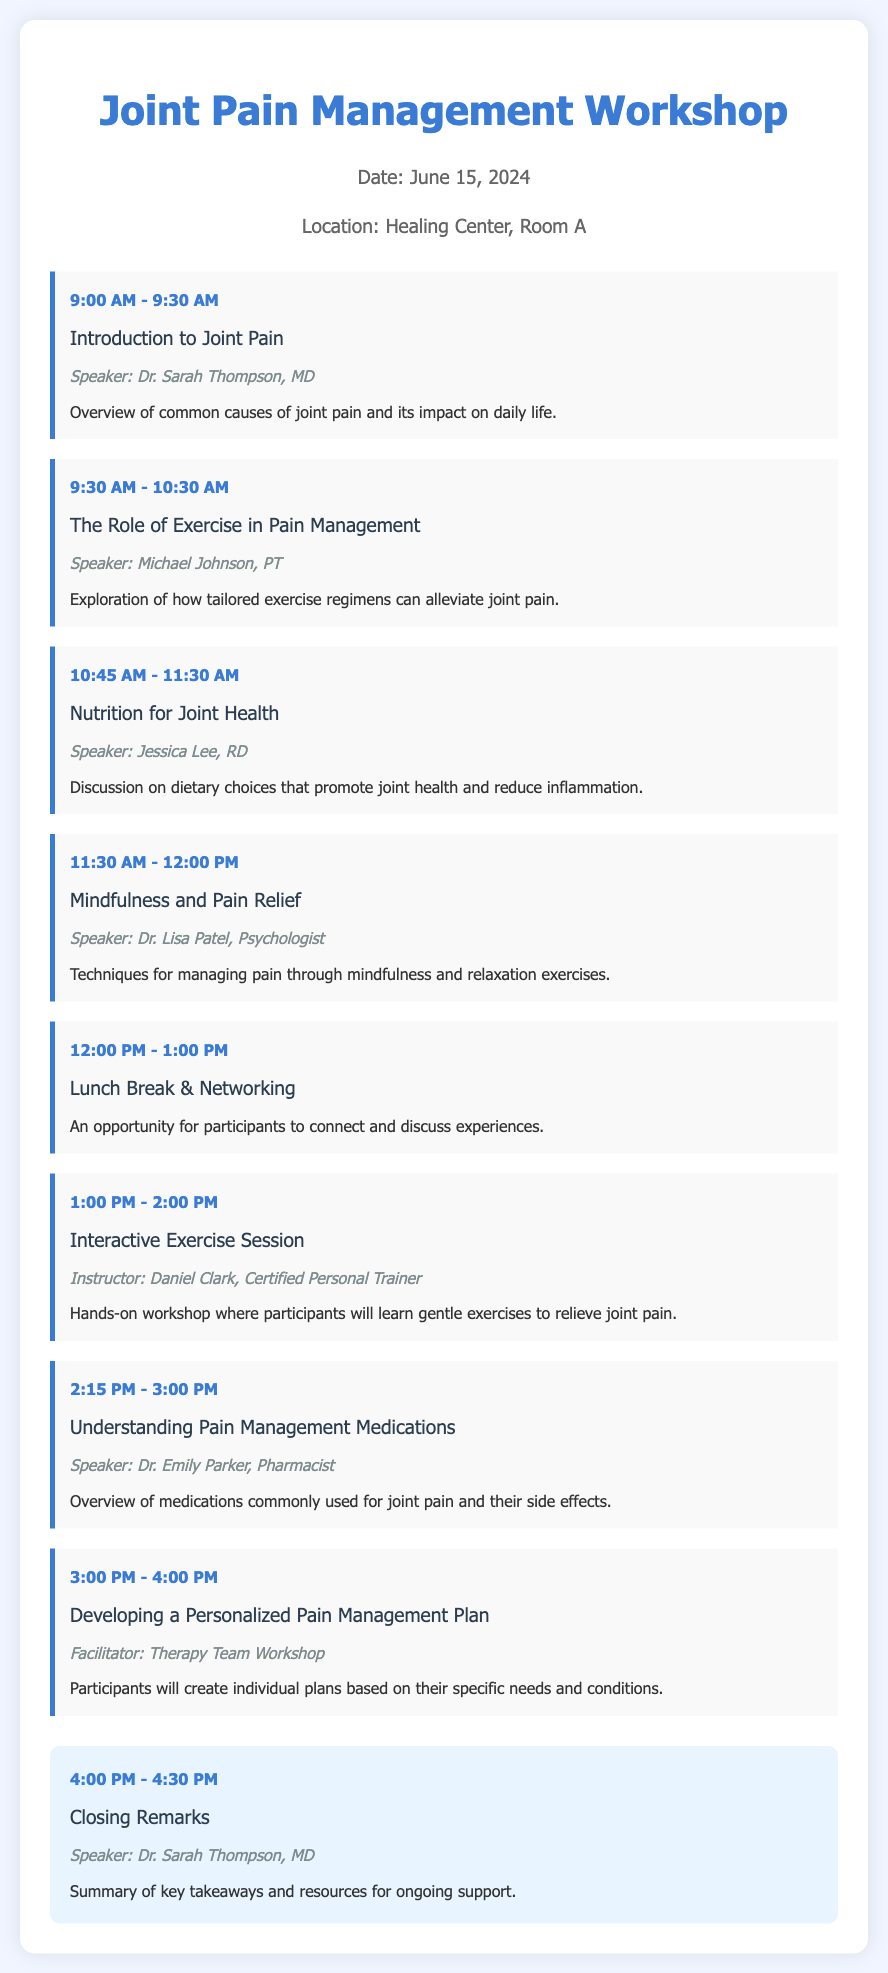What is the date of the workshop? The date of the workshop is clearly stated in the workshop information section of the document.
Answer: June 15, 2024 Who is the speaker for the session on Nutrition for Joint Health? The speaker's name for this specific session is mentioned right under the session title, detailing who will lead the discussion.
Answer: Jessica Lee, RD What time does the lunch break start? The start time of the lunch break is indicated in the agenda list, specifically in the session titled "Lunch Break & Networking."
Answer: 12:00 PM What are participants expected to do during the Interactive Exercise Session? This session's description highlights the main activity that will take place during the workshop, focusing on participant involvement.
Answer: Learn gentle exercises to relieve joint pain Who will provide the closing remarks? The document specifies the speaker for the closing remarks, as it is listed under the closing section.
Answer: Dr. Sarah Thompson, MD How long is the session on Understanding Pain Management Medications? The duration of this session is mentioned in the agenda, highlighting the specific time allotted for it.
Answer: 45 minutes What topic is addressed at 10:45 AM? The agenda provides the specific title of the session occurring at this time, making it clear and easy to identify.
Answer: Nutrition for Joint Health What will participants create in the session titled Developing a Personalized Pain Management Plan? The description under this session outlines the activity that participants will engage in during this workshop segment.
Answer: Individual plans based on their specific needs and conditions 